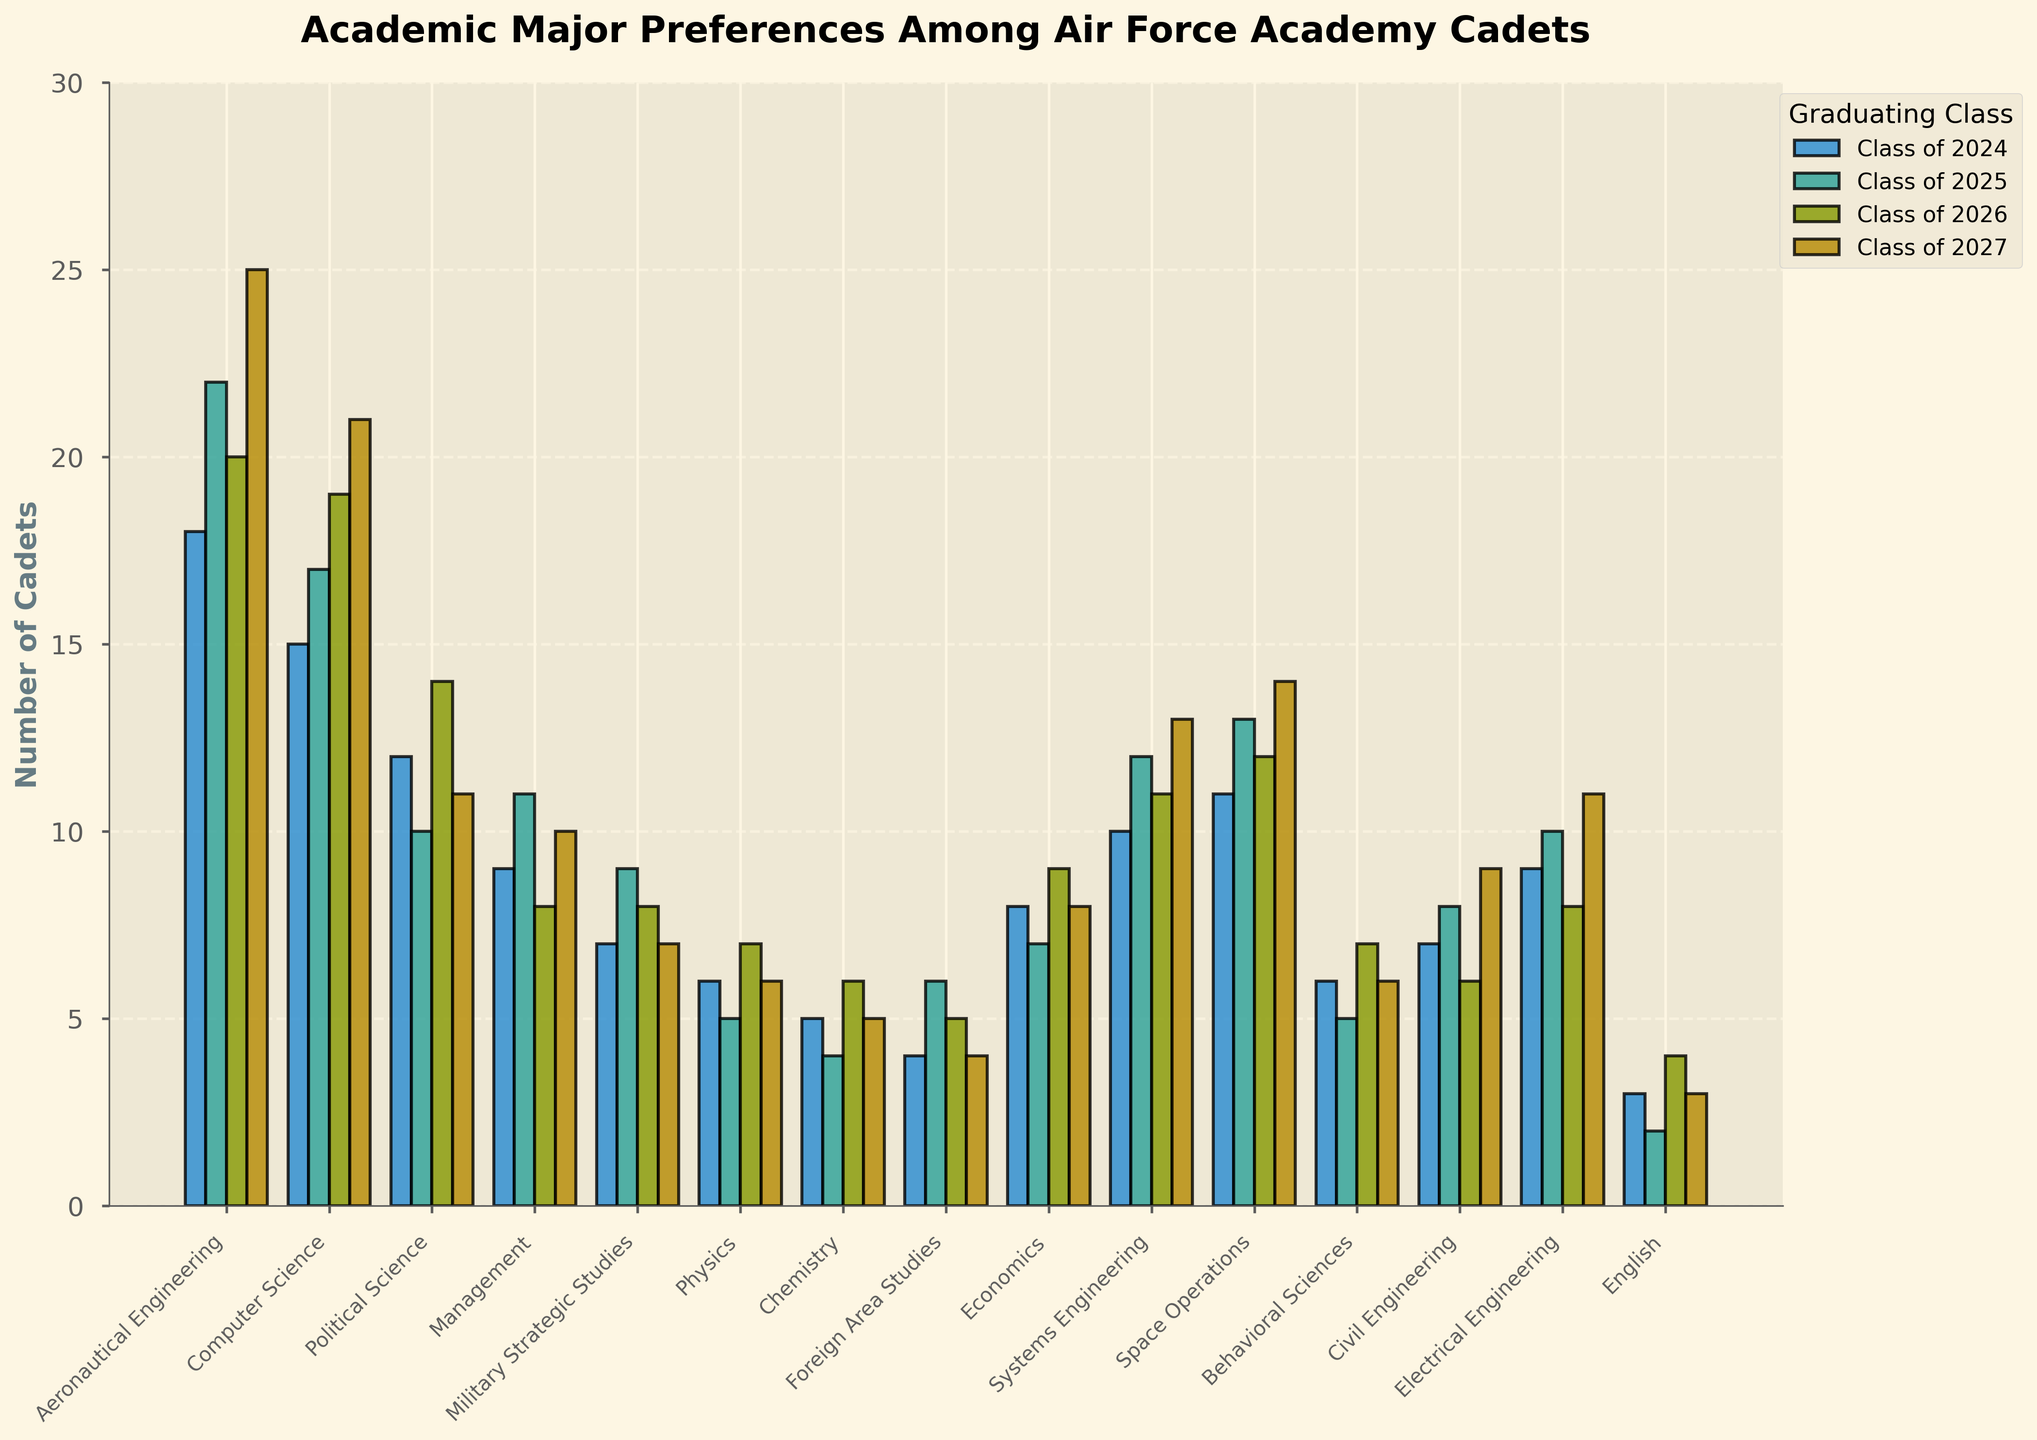Which major has the highest number of cadets in the Class of 2027? Observe the bars corresponding to the Class of 2027. The tallest bar represents Aeronautical Engineering at 25 cadets.
Answer: Aeronautical Engineering Which major has the fewest cadets across all graduating classes? Look for the shortest bar in each group of bars across all years. The shortest bar overall represents English for the Class of 2025, with 2 cadets.
Answer: English How does the number of cadets in Computer Science change from the Class of 2024 to the Class of 2027? Compare the height of the bars for Computer Science across the four classes. It increases from 15 (2024) to 17 (2025), then to 19 (2026), and finally reaches 21 (2027).
Answer: It increases Compare the number of cadets in Political Science between the Class of 2024 and the Class of 2027. Look at the bars for Political Science for both class years. For the Class of 2024, there are 12 cadets, and for the Class of 2027, there are 11 cadets.
Answer: 1 fewer in 2027 Which majors have the same number of cadets in the Class of 2026? Identify bars of equal height for the Class of 2026. Both Military Strategic Studies and Behavioral Sciences have 8 cadets each.
Answer: Military Strategic Studies, Behavioral Sciences Calculate the average number of cadets in Systems Engineering across all graduating classes. Add the numbers for all years (10 + 12 + 11 + 13) and divide by 4. (10+12+11+13)/4 = 11.5
Answer: 11.5 Which year saw the highest enrollment in Civil Engineering? Compare the height of the bars for Civil Engineering across the four classes. The highest bar corresponds to the Class of 2027 with 9 cadets.
Answer: Class of 2027 Did the number of cadets in Political Science increase or decrease from the Class of 2025 to the Class of 2026? Compare the bars for Political Science between the Class of 2025 (10 cadets) and the Class of 2026 (14 cadets).
Answer: Increase Which major had the same number of cadets in the Class of 2025 and the Class of 2027? Look for bars of equal height for both specified years. Foreign Area Studies has 6 cadets each year.
Answer: Foreign Area Studies Sum the number of cadets in Aeronautical Engineering and Computer Science for the Class of 2026. Add the cadet counts for both majors in the Class of 2026. Aeronautical Engineering: 20, Computer Science: 19. 20 + 19 = 39
Answer: 39 